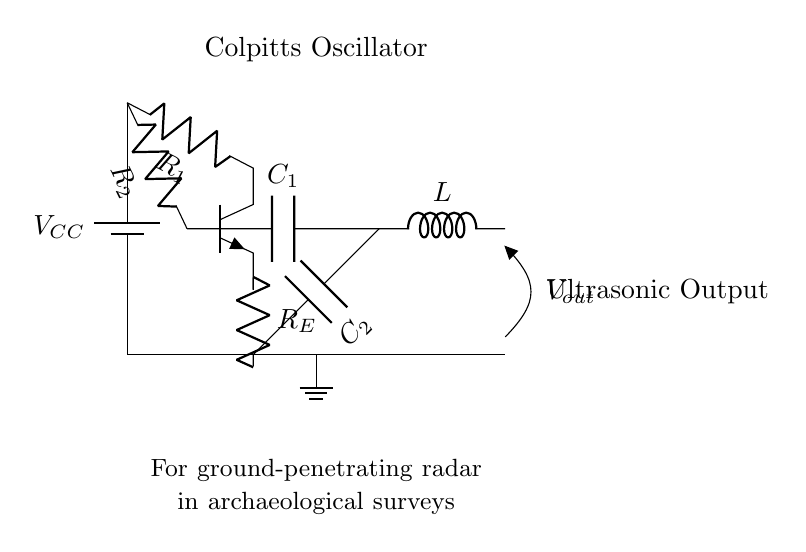What type of oscillator is depicted in the circuit? The circuit is labeled as a "Colpitts Oscillator," which indicates the type of oscillator used. Colpitts oscillators typically make use of a combination of capacitors for frequency determination.
Answer: Colpitts Oscillator What is the purpose of this circuit? The explanatory text notes that the oscillator is designed for "ground-penetrating radar in archaeological surveys," which specifies its use. Ground-penetrating radar systems utilize ultrasonic waves for subsurface imaging.
Answer: Ultrasonic output How many capacitors are in the circuit? The diagram shows two capacitors labeled as C1 and C2, indicating that there are two capacitors used in this oscillator circuit configuration.
Answer: Two What component acts as the active element in this circuit? The transistor, labeled as npn in the diagram, serves as the active component in the Colpitts oscillator circuit, allowing for the amplification and generation of oscillations.
Answer: Transistor What is the role of the inductor in the circuit? In Colpitts oscillators, the inductor is involved in the frequency generation along with the capacitors. The oscillation frequency is determined by the values of the capacitors and the inductor, establishing the resonance condition.
Answer: Frequency generation What is the voltage source in the circuit? The circuit has a battery labeled as Vcc providing the necessary power supply voltage for the functioning of the oscillator circuit components.
Answer: Vcc What is the output voltage labeled as in the diagram? The output of the circuit is indicated as Vout, which represents the voltage output produced by the Colpitts oscillator. This output is used to generate the ultrasonic waves needed for ground-penetrating radar.
Answer: Vout 